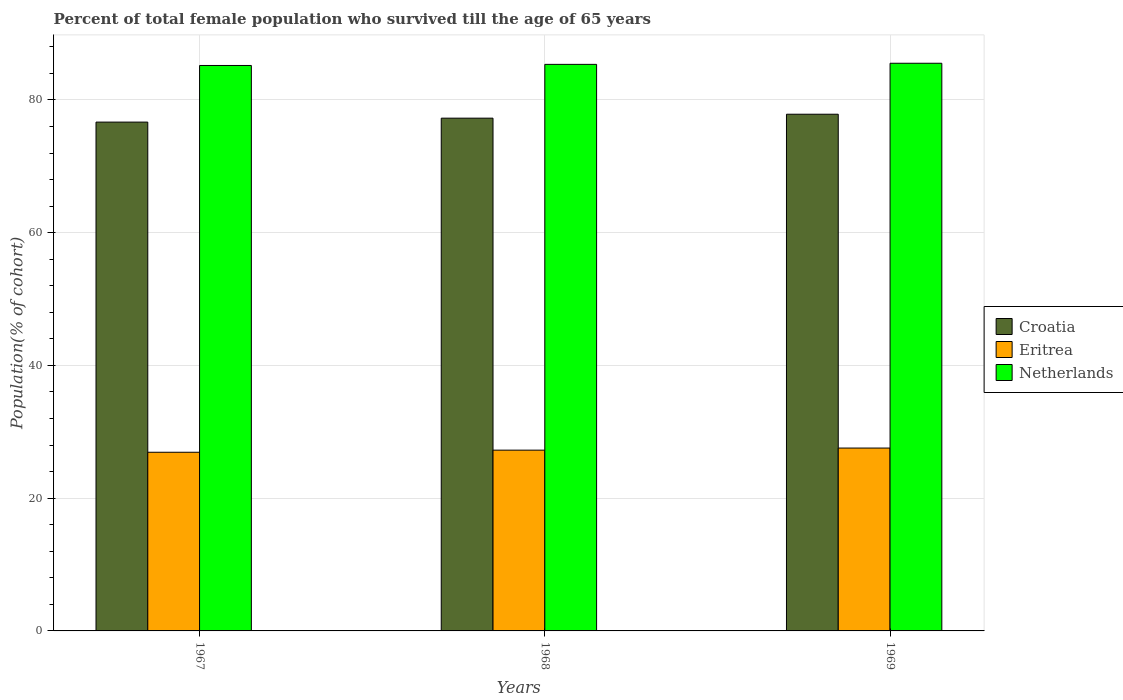How many different coloured bars are there?
Your response must be concise. 3. Are the number of bars per tick equal to the number of legend labels?
Your answer should be compact. Yes. How many bars are there on the 3rd tick from the right?
Ensure brevity in your answer.  3. What is the label of the 1st group of bars from the left?
Give a very brief answer. 1967. What is the percentage of total female population who survived till the age of 65 years in Netherlands in 1968?
Your answer should be very brief. 85.36. Across all years, what is the maximum percentage of total female population who survived till the age of 65 years in Netherlands?
Keep it short and to the point. 85.53. Across all years, what is the minimum percentage of total female population who survived till the age of 65 years in Croatia?
Keep it short and to the point. 76.66. In which year was the percentage of total female population who survived till the age of 65 years in Croatia maximum?
Offer a terse response. 1969. In which year was the percentage of total female population who survived till the age of 65 years in Netherlands minimum?
Your answer should be very brief. 1967. What is the total percentage of total female population who survived till the age of 65 years in Eritrea in the graph?
Offer a terse response. 81.71. What is the difference between the percentage of total female population who survived till the age of 65 years in Eritrea in 1968 and that in 1969?
Ensure brevity in your answer.  -0.32. What is the difference between the percentage of total female population who survived till the age of 65 years in Netherlands in 1968 and the percentage of total female population who survived till the age of 65 years in Eritrea in 1969?
Give a very brief answer. 57.81. What is the average percentage of total female population who survived till the age of 65 years in Croatia per year?
Provide a succinct answer. 77.26. In the year 1969, what is the difference between the percentage of total female population who survived till the age of 65 years in Netherlands and percentage of total female population who survived till the age of 65 years in Croatia?
Give a very brief answer. 7.68. What is the ratio of the percentage of total female population who survived till the age of 65 years in Croatia in 1968 to that in 1969?
Provide a succinct answer. 0.99. Is the difference between the percentage of total female population who survived till the age of 65 years in Netherlands in 1967 and 1968 greater than the difference between the percentage of total female population who survived till the age of 65 years in Croatia in 1967 and 1968?
Offer a very short reply. Yes. What is the difference between the highest and the second highest percentage of total female population who survived till the age of 65 years in Croatia?
Keep it short and to the point. 0.59. What is the difference between the highest and the lowest percentage of total female population who survived till the age of 65 years in Netherlands?
Offer a very short reply. 0.34. Is the sum of the percentage of total female population who survived till the age of 65 years in Netherlands in 1967 and 1968 greater than the maximum percentage of total female population who survived till the age of 65 years in Croatia across all years?
Give a very brief answer. Yes. What does the 1st bar from the left in 1968 represents?
Your answer should be compact. Croatia. What does the 3rd bar from the right in 1968 represents?
Keep it short and to the point. Croatia. How many bars are there?
Ensure brevity in your answer.  9. Are all the bars in the graph horizontal?
Ensure brevity in your answer.  No. Does the graph contain grids?
Your response must be concise. Yes. How many legend labels are there?
Provide a short and direct response. 3. What is the title of the graph?
Your answer should be compact. Percent of total female population who survived till the age of 65 years. What is the label or title of the Y-axis?
Give a very brief answer. Population(% of cohort). What is the Population(% of cohort) of Croatia in 1967?
Offer a very short reply. 76.66. What is the Population(% of cohort) of Eritrea in 1967?
Your answer should be very brief. 26.92. What is the Population(% of cohort) of Netherlands in 1967?
Offer a very short reply. 85.19. What is the Population(% of cohort) in Croatia in 1968?
Ensure brevity in your answer.  77.26. What is the Population(% of cohort) in Eritrea in 1968?
Your response must be concise. 27.24. What is the Population(% of cohort) in Netherlands in 1968?
Provide a short and direct response. 85.36. What is the Population(% of cohort) in Croatia in 1969?
Provide a succinct answer. 77.85. What is the Population(% of cohort) in Eritrea in 1969?
Offer a terse response. 27.55. What is the Population(% of cohort) in Netherlands in 1969?
Provide a short and direct response. 85.53. Across all years, what is the maximum Population(% of cohort) of Croatia?
Offer a very short reply. 77.85. Across all years, what is the maximum Population(% of cohort) in Eritrea?
Keep it short and to the point. 27.55. Across all years, what is the maximum Population(% of cohort) in Netherlands?
Provide a succinct answer. 85.53. Across all years, what is the minimum Population(% of cohort) in Croatia?
Your answer should be very brief. 76.66. Across all years, what is the minimum Population(% of cohort) of Eritrea?
Offer a very short reply. 26.92. Across all years, what is the minimum Population(% of cohort) in Netherlands?
Your answer should be compact. 85.19. What is the total Population(% of cohort) of Croatia in the graph?
Offer a very short reply. 231.77. What is the total Population(% of cohort) of Eritrea in the graph?
Provide a succinct answer. 81.71. What is the total Population(% of cohort) in Netherlands in the graph?
Ensure brevity in your answer.  256.08. What is the difference between the Population(% of cohort) of Croatia in 1967 and that in 1968?
Provide a short and direct response. -0.59. What is the difference between the Population(% of cohort) in Eritrea in 1967 and that in 1968?
Provide a succinct answer. -0.32. What is the difference between the Population(% of cohort) of Netherlands in 1967 and that in 1968?
Provide a short and direct response. -0.17. What is the difference between the Population(% of cohort) of Croatia in 1967 and that in 1969?
Keep it short and to the point. -1.19. What is the difference between the Population(% of cohort) in Eritrea in 1967 and that in 1969?
Ensure brevity in your answer.  -0.63. What is the difference between the Population(% of cohort) in Netherlands in 1967 and that in 1969?
Give a very brief answer. -0.34. What is the difference between the Population(% of cohort) in Croatia in 1968 and that in 1969?
Ensure brevity in your answer.  -0.59. What is the difference between the Population(% of cohort) of Eritrea in 1968 and that in 1969?
Ensure brevity in your answer.  -0.32. What is the difference between the Population(% of cohort) in Netherlands in 1968 and that in 1969?
Your response must be concise. -0.17. What is the difference between the Population(% of cohort) in Croatia in 1967 and the Population(% of cohort) in Eritrea in 1968?
Provide a short and direct response. 49.43. What is the difference between the Population(% of cohort) in Croatia in 1967 and the Population(% of cohort) in Netherlands in 1968?
Keep it short and to the point. -8.7. What is the difference between the Population(% of cohort) of Eritrea in 1967 and the Population(% of cohort) of Netherlands in 1968?
Provide a short and direct response. -58.44. What is the difference between the Population(% of cohort) of Croatia in 1967 and the Population(% of cohort) of Eritrea in 1969?
Keep it short and to the point. 49.11. What is the difference between the Population(% of cohort) of Croatia in 1967 and the Population(% of cohort) of Netherlands in 1969?
Your answer should be compact. -8.87. What is the difference between the Population(% of cohort) in Eritrea in 1967 and the Population(% of cohort) in Netherlands in 1969?
Make the answer very short. -58.61. What is the difference between the Population(% of cohort) of Croatia in 1968 and the Population(% of cohort) of Eritrea in 1969?
Offer a very short reply. 49.7. What is the difference between the Population(% of cohort) in Croatia in 1968 and the Population(% of cohort) in Netherlands in 1969?
Provide a short and direct response. -8.27. What is the difference between the Population(% of cohort) in Eritrea in 1968 and the Population(% of cohort) in Netherlands in 1969?
Make the answer very short. -58.29. What is the average Population(% of cohort) of Croatia per year?
Your answer should be compact. 77.26. What is the average Population(% of cohort) of Eritrea per year?
Give a very brief answer. 27.24. What is the average Population(% of cohort) of Netherlands per year?
Make the answer very short. 85.36. In the year 1967, what is the difference between the Population(% of cohort) of Croatia and Population(% of cohort) of Eritrea?
Make the answer very short. 49.74. In the year 1967, what is the difference between the Population(% of cohort) of Croatia and Population(% of cohort) of Netherlands?
Your answer should be very brief. -8.53. In the year 1967, what is the difference between the Population(% of cohort) in Eritrea and Population(% of cohort) in Netherlands?
Provide a short and direct response. -58.27. In the year 1968, what is the difference between the Population(% of cohort) in Croatia and Population(% of cohort) in Eritrea?
Provide a short and direct response. 50.02. In the year 1968, what is the difference between the Population(% of cohort) in Croatia and Population(% of cohort) in Netherlands?
Your answer should be very brief. -8.11. In the year 1968, what is the difference between the Population(% of cohort) of Eritrea and Population(% of cohort) of Netherlands?
Provide a short and direct response. -58.13. In the year 1969, what is the difference between the Population(% of cohort) of Croatia and Population(% of cohort) of Eritrea?
Provide a succinct answer. 50.3. In the year 1969, what is the difference between the Population(% of cohort) of Croatia and Population(% of cohort) of Netherlands?
Your response must be concise. -7.68. In the year 1969, what is the difference between the Population(% of cohort) in Eritrea and Population(% of cohort) in Netherlands?
Give a very brief answer. -57.98. What is the ratio of the Population(% of cohort) in Eritrea in 1967 to that in 1968?
Provide a short and direct response. 0.99. What is the ratio of the Population(% of cohort) in Croatia in 1967 to that in 1969?
Your response must be concise. 0.98. What is the ratio of the Population(% of cohort) in Eritrea in 1967 to that in 1969?
Your response must be concise. 0.98. What is the ratio of the Population(% of cohort) of Netherlands in 1967 to that in 1969?
Your answer should be compact. 1. What is the difference between the highest and the second highest Population(% of cohort) in Croatia?
Provide a succinct answer. 0.59. What is the difference between the highest and the second highest Population(% of cohort) of Eritrea?
Ensure brevity in your answer.  0.32. What is the difference between the highest and the second highest Population(% of cohort) of Netherlands?
Provide a succinct answer. 0.17. What is the difference between the highest and the lowest Population(% of cohort) in Croatia?
Make the answer very short. 1.19. What is the difference between the highest and the lowest Population(% of cohort) of Eritrea?
Provide a succinct answer. 0.63. What is the difference between the highest and the lowest Population(% of cohort) in Netherlands?
Your response must be concise. 0.34. 